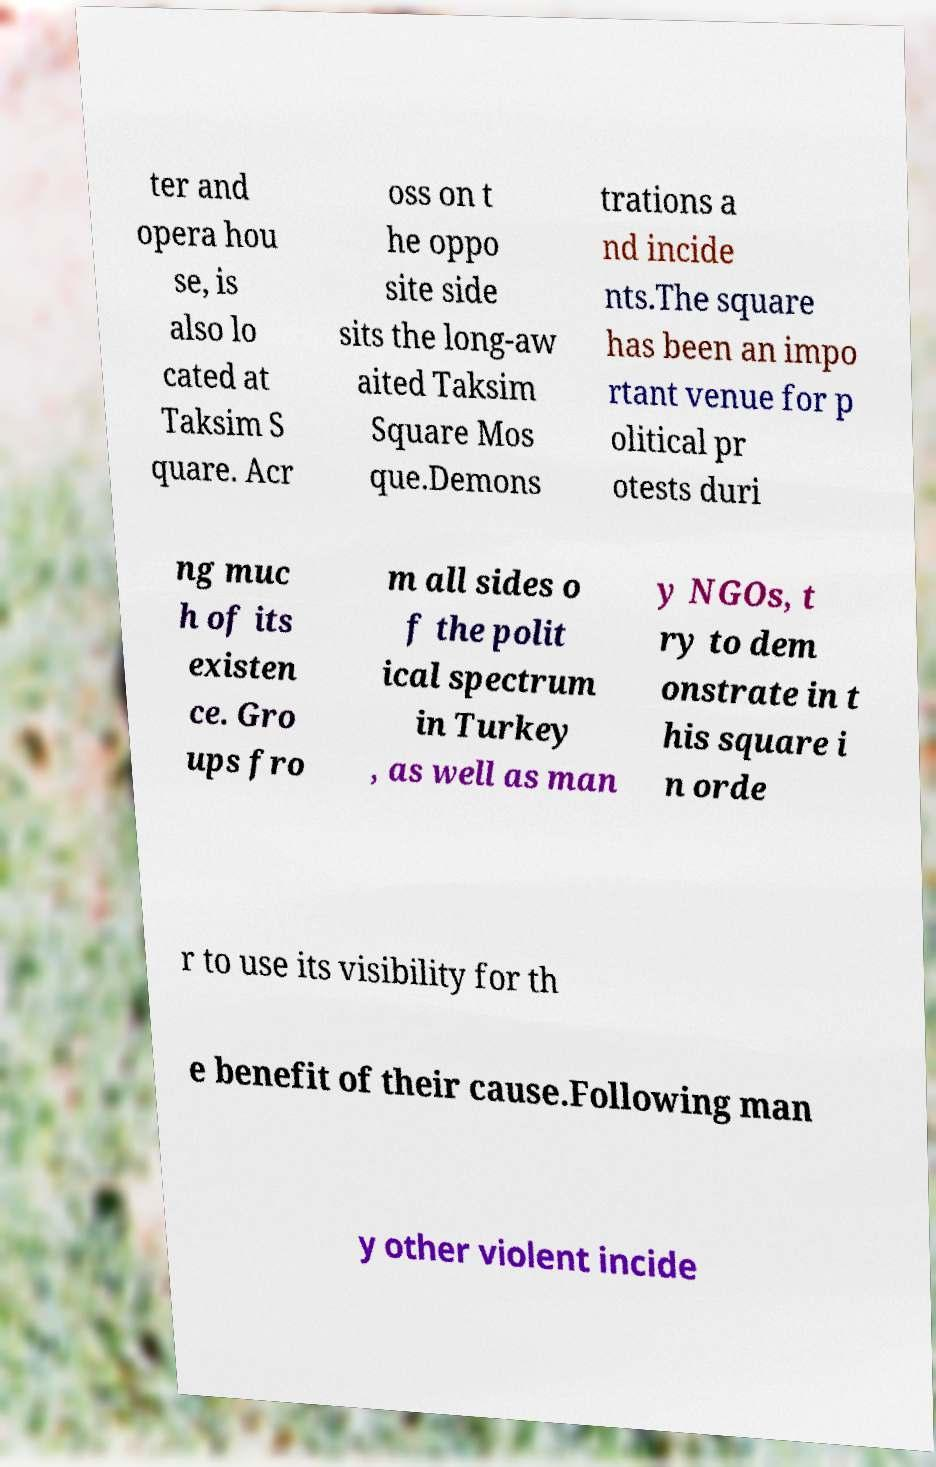Please identify and transcribe the text found in this image. ter and opera hou se, is also lo cated at Taksim S quare. Acr oss on t he oppo site side sits the long-aw aited Taksim Square Mos que.Demons trations a nd incide nts.The square has been an impo rtant venue for p olitical pr otests duri ng muc h of its existen ce. Gro ups fro m all sides o f the polit ical spectrum in Turkey , as well as man y NGOs, t ry to dem onstrate in t his square i n orde r to use its visibility for th e benefit of their cause.Following man y other violent incide 